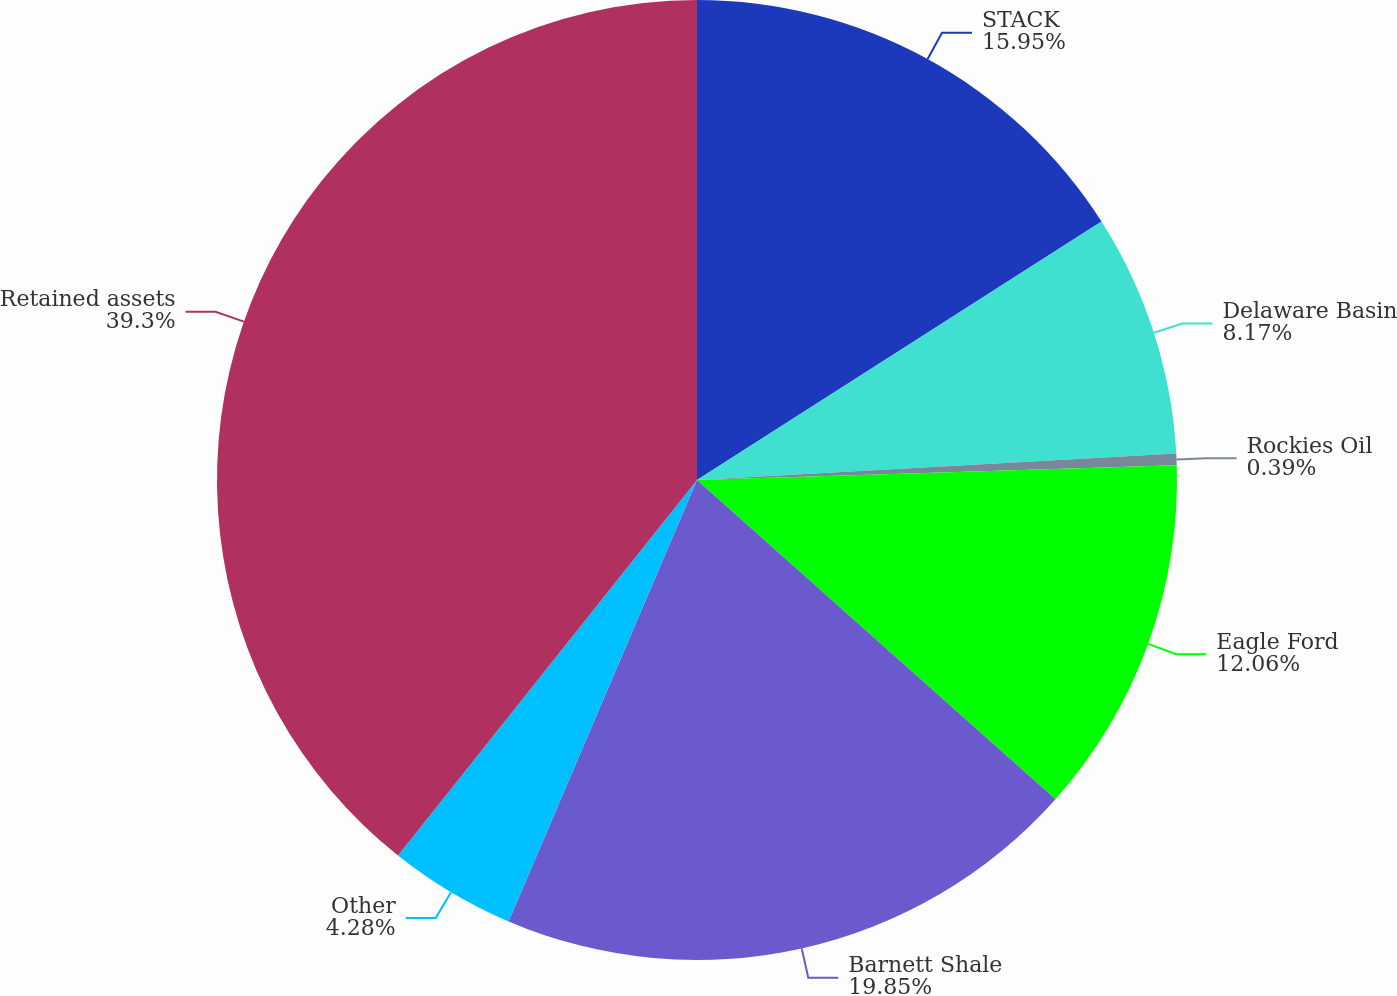<chart> <loc_0><loc_0><loc_500><loc_500><pie_chart><fcel>STACK<fcel>Delaware Basin<fcel>Rockies Oil<fcel>Eagle Ford<fcel>Barnett Shale<fcel>Other<fcel>Retained assets<nl><fcel>15.95%<fcel>8.17%<fcel>0.39%<fcel>12.06%<fcel>19.84%<fcel>4.28%<fcel>39.29%<nl></chart> 